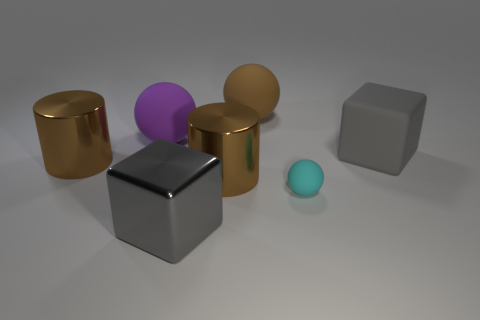Subtract all blue cylinders. Subtract all green cubes. How many cylinders are left? 2 Add 2 purple balls. How many objects exist? 9 Subtract all blocks. How many objects are left? 5 Subtract all brown rubber balls. Subtract all large rubber objects. How many objects are left? 3 Add 6 cyan balls. How many cyan balls are left? 7 Add 2 big things. How many big things exist? 8 Subtract 0 brown blocks. How many objects are left? 7 